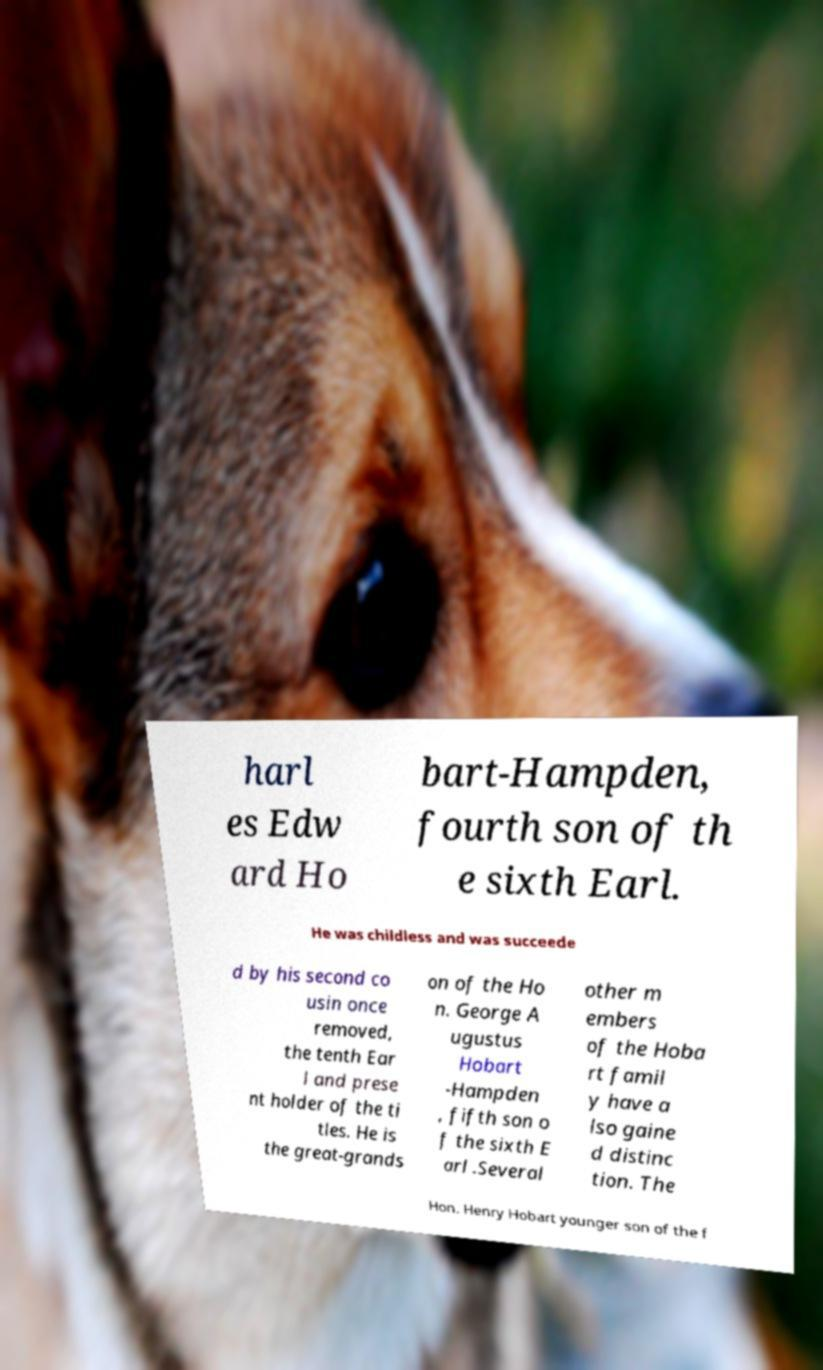Please identify and transcribe the text found in this image. harl es Edw ard Ho bart-Hampden, fourth son of th e sixth Earl. He was childless and was succeede d by his second co usin once removed, the tenth Ear l and prese nt holder of the ti tles. He is the great-grands on of the Ho n. George A ugustus Hobart -Hampden , fifth son o f the sixth E arl .Several other m embers of the Hoba rt famil y have a lso gaine d distinc tion. The Hon. Henry Hobart younger son of the f 